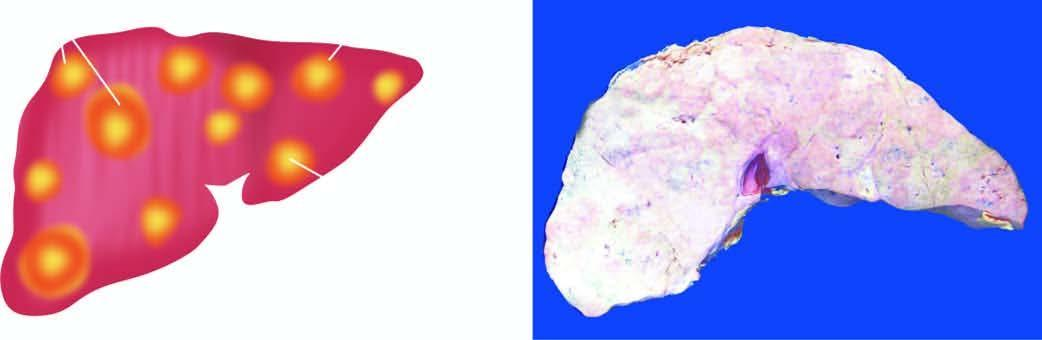what is seen on sectioned surface?
Answer the question using a single word or phrase. Metastatic tumour deposits in the liver 